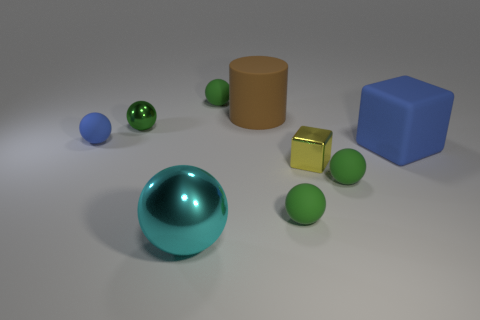How many green spheres must be subtracted to get 2 green spheres? 2 Subtract all cyan spheres. How many spheres are left? 5 Add 1 blocks. How many objects exist? 10 Subtract 1 blocks. How many blocks are left? 1 Subtract all blue spheres. How many spheres are left? 5 Subtract all cylinders. How many objects are left? 8 Subtract 0 green cylinders. How many objects are left? 9 Subtract all blue cylinders. Subtract all brown spheres. How many cylinders are left? 1 Subtract all gray blocks. How many brown balls are left? 0 Subtract all blue matte things. Subtract all green metallic balls. How many objects are left? 6 